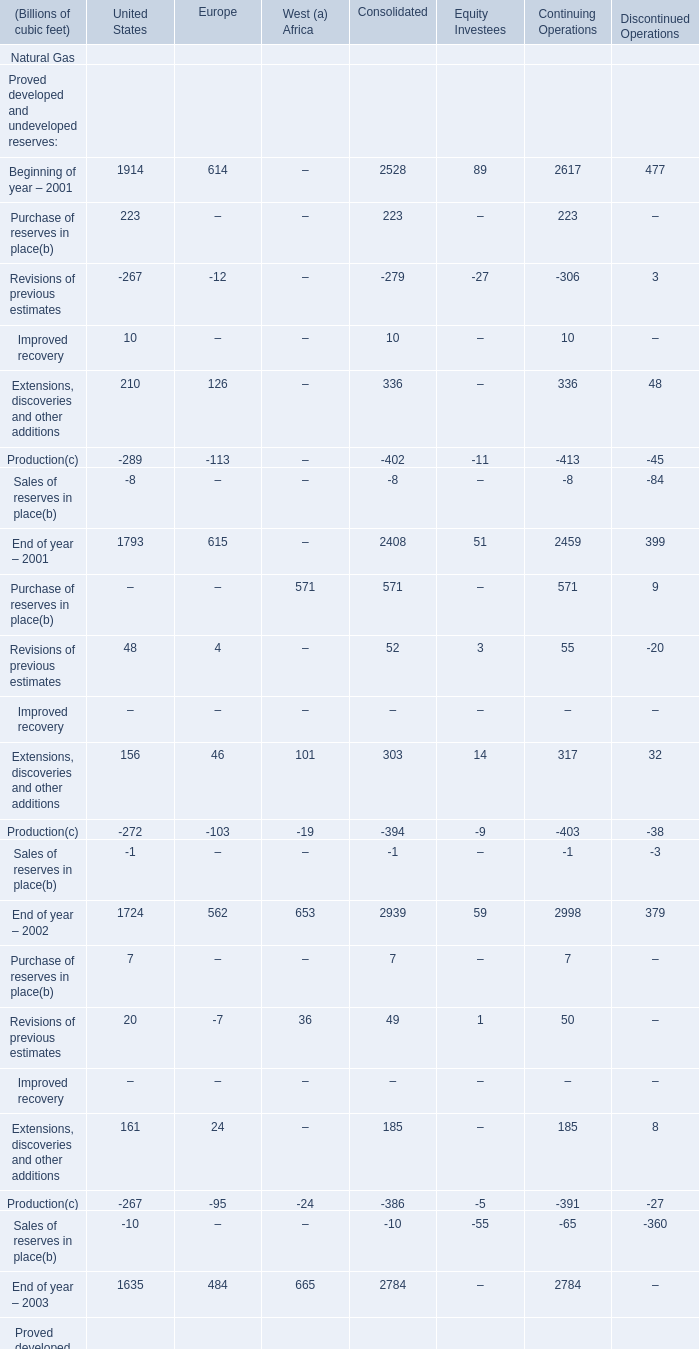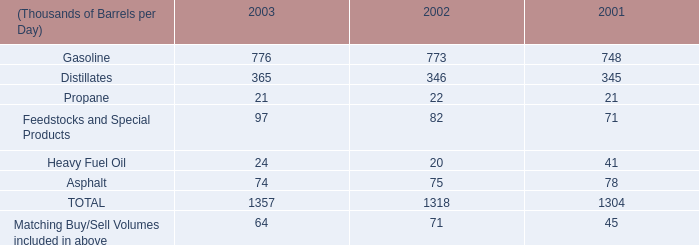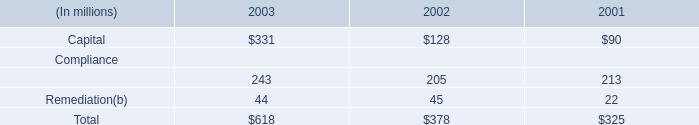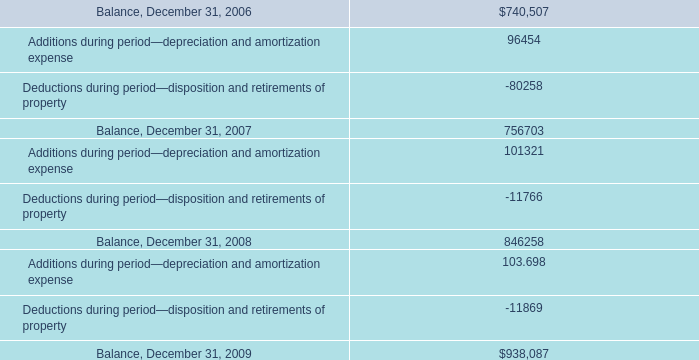what is the percentual decline of the deductions during 2007 and 2008? 
Computations: ((11766 - 80258) / 80258)
Answer: -0.8534. 